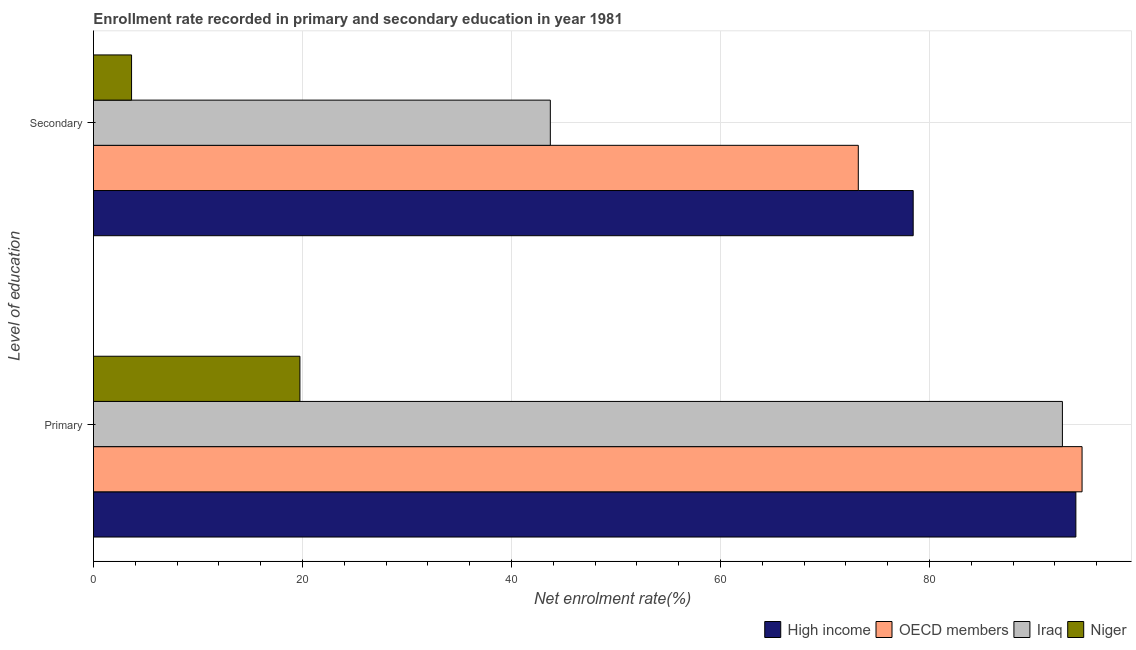How many bars are there on the 1st tick from the bottom?
Your answer should be compact. 4. What is the label of the 1st group of bars from the top?
Your response must be concise. Secondary. What is the enrollment rate in secondary education in OECD members?
Offer a very short reply. 73.2. Across all countries, what is the maximum enrollment rate in secondary education?
Provide a short and direct response. 78.45. Across all countries, what is the minimum enrollment rate in secondary education?
Ensure brevity in your answer.  3.65. In which country was the enrollment rate in primary education minimum?
Make the answer very short. Niger. What is the total enrollment rate in primary education in the graph?
Give a very brief answer. 301.11. What is the difference between the enrollment rate in primary education in Niger and that in High income?
Offer a terse response. -74.26. What is the difference between the enrollment rate in secondary education in High income and the enrollment rate in primary education in Niger?
Your answer should be compact. 58.69. What is the average enrollment rate in secondary education per country?
Offer a very short reply. 49.75. What is the difference between the enrollment rate in secondary education and enrollment rate in primary education in High income?
Offer a very short reply. -15.57. What is the ratio of the enrollment rate in primary education in High income to that in Niger?
Your answer should be very brief. 4.76. What does the 1st bar from the top in Primary represents?
Your answer should be very brief. Niger. Are all the bars in the graph horizontal?
Make the answer very short. Yes. How many countries are there in the graph?
Provide a short and direct response. 4. What is the difference between two consecutive major ticks on the X-axis?
Your response must be concise. 20. Does the graph contain any zero values?
Your answer should be very brief. No. Where does the legend appear in the graph?
Offer a very short reply. Bottom right. How are the legend labels stacked?
Your response must be concise. Horizontal. What is the title of the graph?
Offer a very short reply. Enrollment rate recorded in primary and secondary education in year 1981. What is the label or title of the X-axis?
Offer a terse response. Net enrolment rate(%). What is the label or title of the Y-axis?
Offer a terse response. Level of education. What is the Net enrolment rate(%) in High income in Primary?
Your response must be concise. 94.02. What is the Net enrolment rate(%) in OECD members in Primary?
Your response must be concise. 94.61. What is the Net enrolment rate(%) in Iraq in Primary?
Your answer should be very brief. 92.73. What is the Net enrolment rate(%) of Niger in Primary?
Keep it short and to the point. 19.76. What is the Net enrolment rate(%) of High income in Secondary?
Your response must be concise. 78.45. What is the Net enrolment rate(%) in OECD members in Secondary?
Offer a very short reply. 73.2. What is the Net enrolment rate(%) of Iraq in Secondary?
Ensure brevity in your answer.  43.72. What is the Net enrolment rate(%) of Niger in Secondary?
Give a very brief answer. 3.65. Across all Level of education, what is the maximum Net enrolment rate(%) of High income?
Give a very brief answer. 94.02. Across all Level of education, what is the maximum Net enrolment rate(%) in OECD members?
Your answer should be very brief. 94.61. Across all Level of education, what is the maximum Net enrolment rate(%) of Iraq?
Offer a terse response. 92.73. Across all Level of education, what is the maximum Net enrolment rate(%) in Niger?
Offer a very short reply. 19.76. Across all Level of education, what is the minimum Net enrolment rate(%) in High income?
Keep it short and to the point. 78.45. Across all Level of education, what is the minimum Net enrolment rate(%) in OECD members?
Provide a succinct answer. 73.2. Across all Level of education, what is the minimum Net enrolment rate(%) of Iraq?
Ensure brevity in your answer.  43.72. Across all Level of education, what is the minimum Net enrolment rate(%) in Niger?
Give a very brief answer. 3.65. What is the total Net enrolment rate(%) in High income in the graph?
Make the answer very short. 172.47. What is the total Net enrolment rate(%) in OECD members in the graph?
Ensure brevity in your answer.  167.81. What is the total Net enrolment rate(%) in Iraq in the graph?
Provide a succinct answer. 136.45. What is the total Net enrolment rate(%) of Niger in the graph?
Offer a terse response. 23.4. What is the difference between the Net enrolment rate(%) of High income in Primary and that in Secondary?
Provide a short and direct response. 15.57. What is the difference between the Net enrolment rate(%) of OECD members in Primary and that in Secondary?
Your answer should be very brief. 21.41. What is the difference between the Net enrolment rate(%) of Iraq in Primary and that in Secondary?
Give a very brief answer. 49.01. What is the difference between the Net enrolment rate(%) of Niger in Primary and that in Secondary?
Your answer should be compact. 16.11. What is the difference between the Net enrolment rate(%) of High income in Primary and the Net enrolment rate(%) of OECD members in Secondary?
Provide a succinct answer. 20.82. What is the difference between the Net enrolment rate(%) of High income in Primary and the Net enrolment rate(%) of Iraq in Secondary?
Provide a succinct answer. 50.3. What is the difference between the Net enrolment rate(%) of High income in Primary and the Net enrolment rate(%) of Niger in Secondary?
Give a very brief answer. 90.37. What is the difference between the Net enrolment rate(%) in OECD members in Primary and the Net enrolment rate(%) in Iraq in Secondary?
Provide a short and direct response. 50.89. What is the difference between the Net enrolment rate(%) in OECD members in Primary and the Net enrolment rate(%) in Niger in Secondary?
Offer a terse response. 90.96. What is the difference between the Net enrolment rate(%) of Iraq in Primary and the Net enrolment rate(%) of Niger in Secondary?
Give a very brief answer. 89.08. What is the average Net enrolment rate(%) of High income per Level of education?
Give a very brief answer. 86.23. What is the average Net enrolment rate(%) of OECD members per Level of education?
Keep it short and to the point. 83.9. What is the average Net enrolment rate(%) in Iraq per Level of education?
Give a very brief answer. 68.23. What is the average Net enrolment rate(%) in Niger per Level of education?
Keep it short and to the point. 11.7. What is the difference between the Net enrolment rate(%) in High income and Net enrolment rate(%) in OECD members in Primary?
Keep it short and to the point. -0.59. What is the difference between the Net enrolment rate(%) in High income and Net enrolment rate(%) in Iraq in Primary?
Offer a terse response. 1.29. What is the difference between the Net enrolment rate(%) in High income and Net enrolment rate(%) in Niger in Primary?
Provide a short and direct response. 74.26. What is the difference between the Net enrolment rate(%) in OECD members and Net enrolment rate(%) in Iraq in Primary?
Your answer should be compact. 1.88. What is the difference between the Net enrolment rate(%) of OECD members and Net enrolment rate(%) of Niger in Primary?
Give a very brief answer. 74.85. What is the difference between the Net enrolment rate(%) of Iraq and Net enrolment rate(%) of Niger in Primary?
Your answer should be compact. 72.97. What is the difference between the Net enrolment rate(%) in High income and Net enrolment rate(%) in OECD members in Secondary?
Your response must be concise. 5.25. What is the difference between the Net enrolment rate(%) of High income and Net enrolment rate(%) of Iraq in Secondary?
Your answer should be very brief. 34.73. What is the difference between the Net enrolment rate(%) in High income and Net enrolment rate(%) in Niger in Secondary?
Offer a very short reply. 74.8. What is the difference between the Net enrolment rate(%) of OECD members and Net enrolment rate(%) of Iraq in Secondary?
Ensure brevity in your answer.  29.47. What is the difference between the Net enrolment rate(%) of OECD members and Net enrolment rate(%) of Niger in Secondary?
Offer a terse response. 69.55. What is the difference between the Net enrolment rate(%) in Iraq and Net enrolment rate(%) in Niger in Secondary?
Your answer should be compact. 40.08. What is the ratio of the Net enrolment rate(%) of High income in Primary to that in Secondary?
Offer a very short reply. 1.2. What is the ratio of the Net enrolment rate(%) of OECD members in Primary to that in Secondary?
Provide a succinct answer. 1.29. What is the ratio of the Net enrolment rate(%) of Iraq in Primary to that in Secondary?
Provide a short and direct response. 2.12. What is the ratio of the Net enrolment rate(%) of Niger in Primary to that in Secondary?
Offer a terse response. 5.42. What is the difference between the highest and the second highest Net enrolment rate(%) of High income?
Give a very brief answer. 15.57. What is the difference between the highest and the second highest Net enrolment rate(%) in OECD members?
Your response must be concise. 21.41. What is the difference between the highest and the second highest Net enrolment rate(%) of Iraq?
Offer a very short reply. 49.01. What is the difference between the highest and the second highest Net enrolment rate(%) in Niger?
Make the answer very short. 16.11. What is the difference between the highest and the lowest Net enrolment rate(%) in High income?
Offer a very short reply. 15.57. What is the difference between the highest and the lowest Net enrolment rate(%) of OECD members?
Make the answer very short. 21.41. What is the difference between the highest and the lowest Net enrolment rate(%) of Iraq?
Your answer should be very brief. 49.01. What is the difference between the highest and the lowest Net enrolment rate(%) of Niger?
Your answer should be very brief. 16.11. 